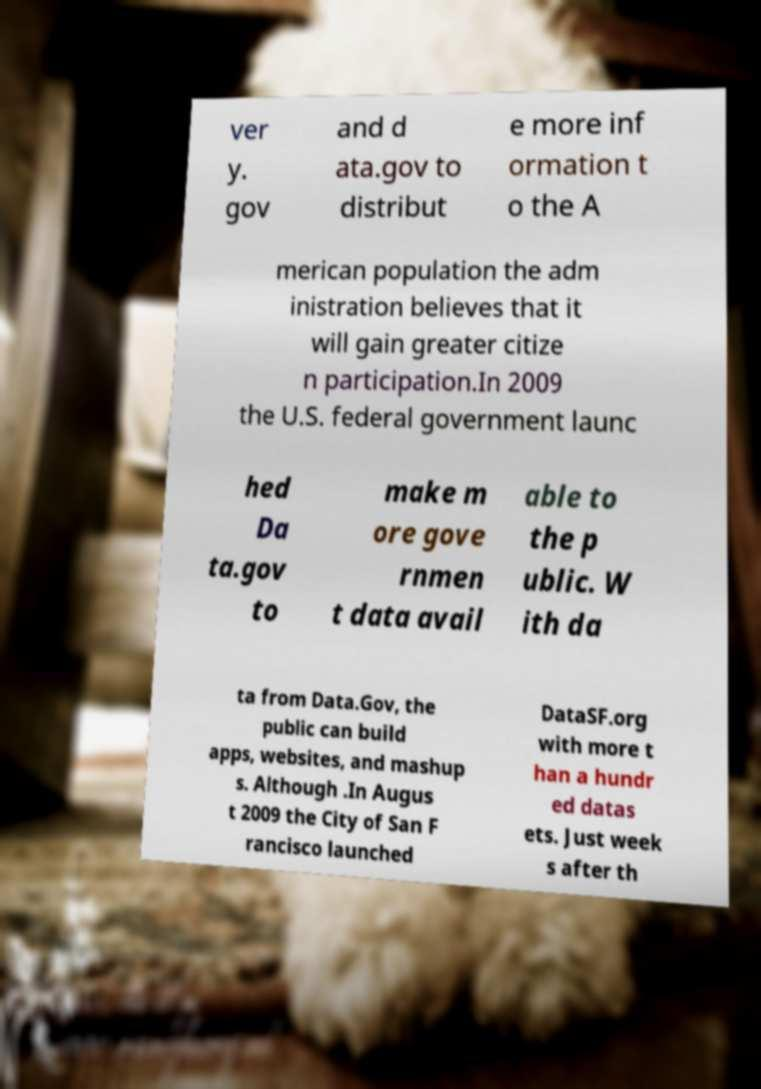Please read and relay the text visible in this image. What does it say? ver y. gov and d ata.gov to distribut e more inf ormation t o the A merican population the adm inistration believes that it will gain greater citize n participation.In 2009 the U.S. federal government launc hed Da ta.gov to make m ore gove rnmen t data avail able to the p ublic. W ith da ta from Data.Gov, the public can build apps, websites, and mashup s. Although .In Augus t 2009 the City of San F rancisco launched DataSF.org with more t han a hundr ed datas ets. Just week s after th 